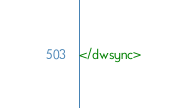<code> <loc_0><loc_0><loc_500><loc_500><_XML_></dwsync></code> 